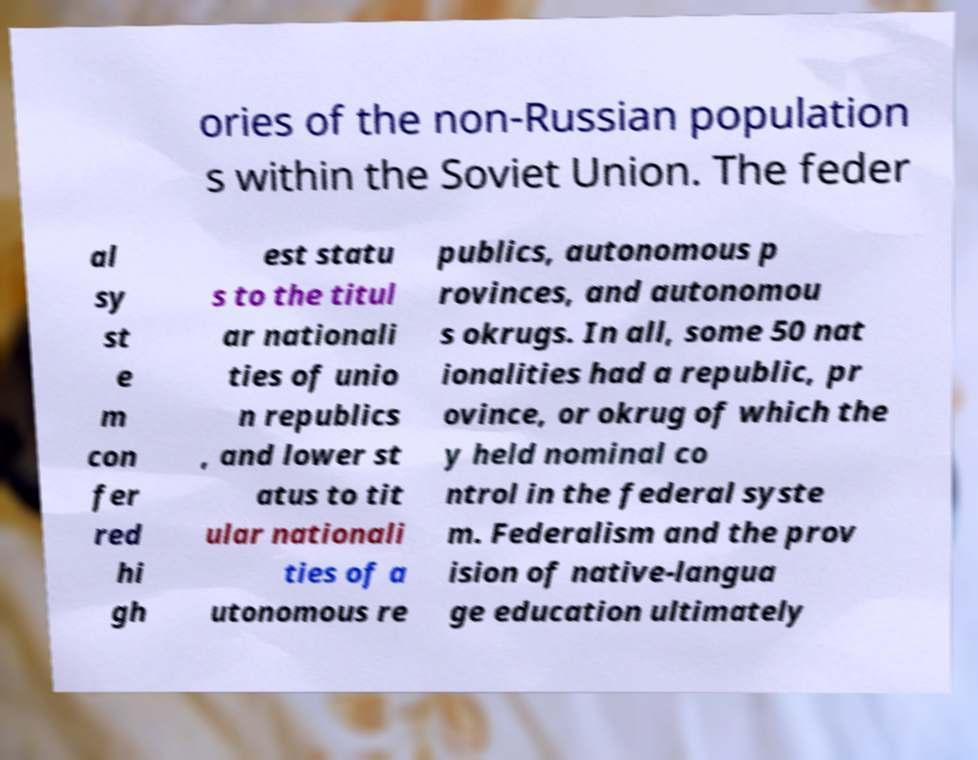Please identify and transcribe the text found in this image. ories of the non-Russian population s within the Soviet Union. The feder al sy st e m con fer red hi gh est statu s to the titul ar nationali ties of unio n republics , and lower st atus to tit ular nationali ties of a utonomous re publics, autonomous p rovinces, and autonomou s okrugs. In all, some 50 nat ionalities had a republic, pr ovince, or okrug of which the y held nominal co ntrol in the federal syste m. Federalism and the prov ision of native-langua ge education ultimately 